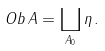<formula> <loc_0><loc_0><loc_500><loc_500>O b \, A = \coprod _ { A _ { 0 } } \eta \, .</formula> 